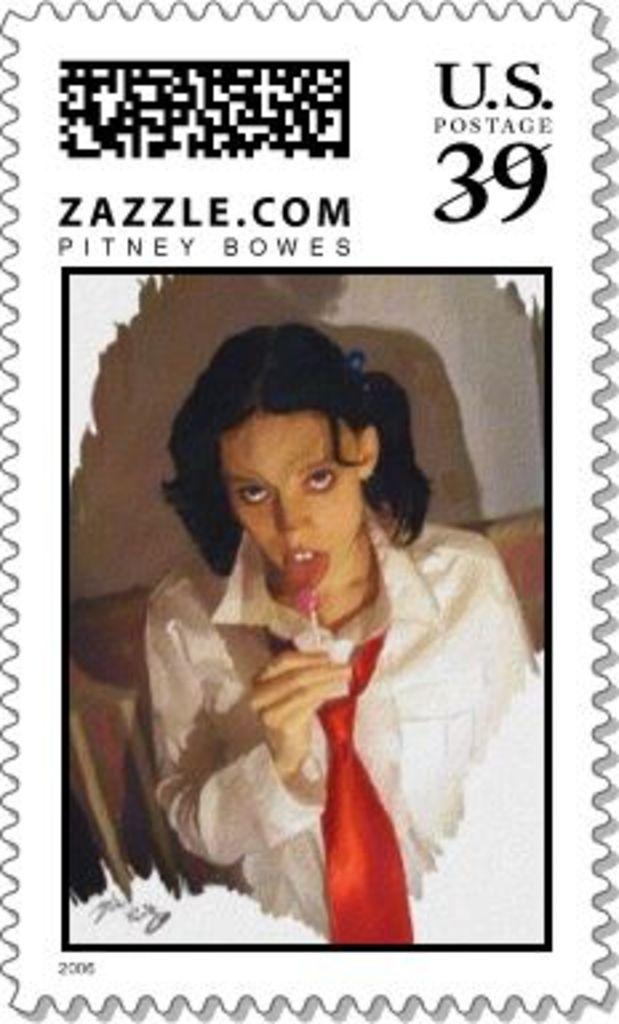What type of image is being described? The image is a poster. What information is present at the top of the poster? There is a barcode and numbers at the top of the poster. Who is featured in the poster? There is a woman in the poster. What is the woman doing in the poster? The woman is eating a lollipop. What furniture is visible in the poster? The woman is standing near a chair and table. Can you see any coils in the poster? There is no mention of coils in the provided facts, so we cannot determine if any are present in the poster. Is the woman at the seashore in the poster? There is no mention of a seashore in the provided facts, so we cannot determine if the woman is at the seashore in the poster. 